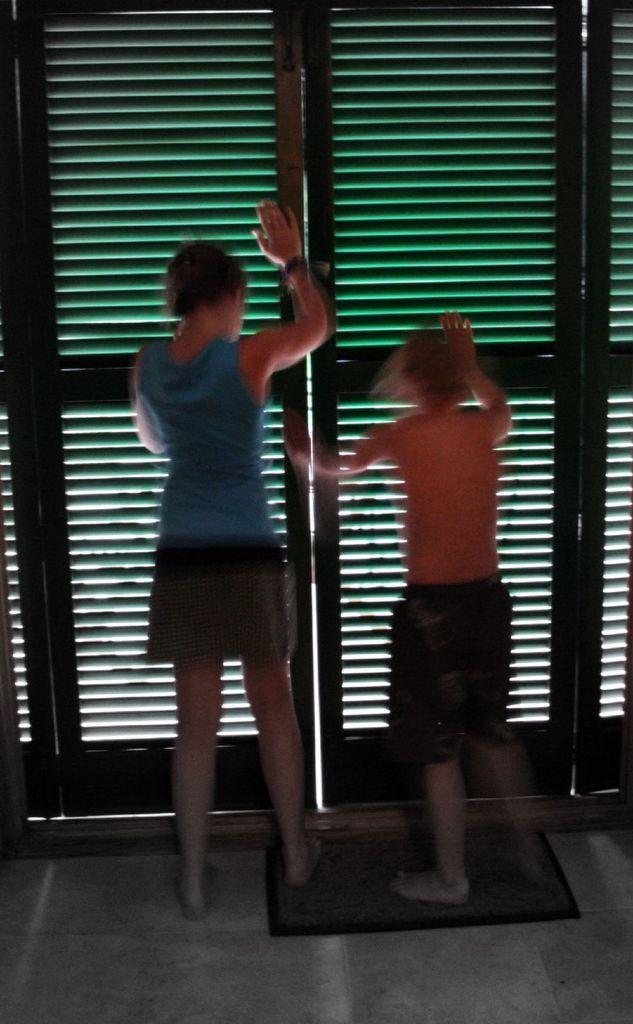Describe this image in one or two sentences. In this image two girls are standing on the door mat on the floor at the doors and pushing the doors. 